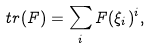<formula> <loc_0><loc_0><loc_500><loc_500>\ t r ( F ) = \sum _ { i } F ( \xi _ { i } ) ^ { i } ,</formula> 